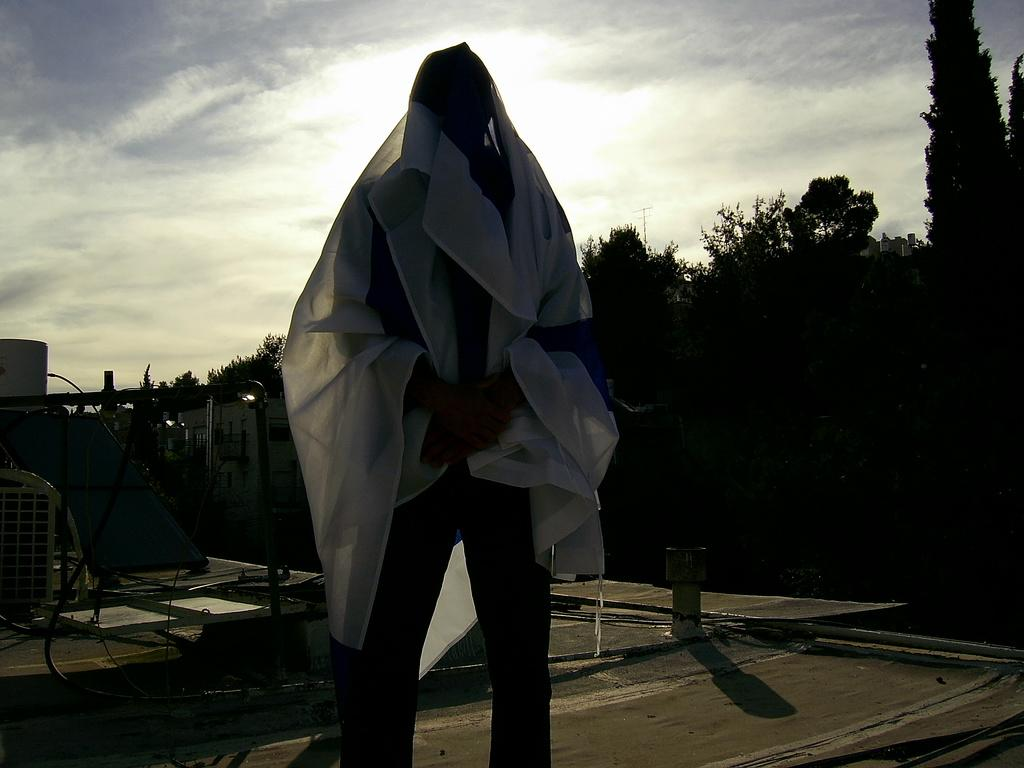Who or what is the main subject in the image? There is a person in the image. What can be seen behind the person? There is a building behind the person. What type of natural elements are present in the image? Trees are present in the image. What else can be seen in the image besides the person and the building? There are other objects in the image. What is visible in the background of the image? The sky is visible in the image. What type of insurance policy is the person holding in the image? There is no insurance policy present in the image; it only features a person, a building, trees, other objects, and the sky. What type of apparel is the person wearing in the image? The provided facts do not mention the person's apparel, so we cannot determine what type of clothing they are wearing. 